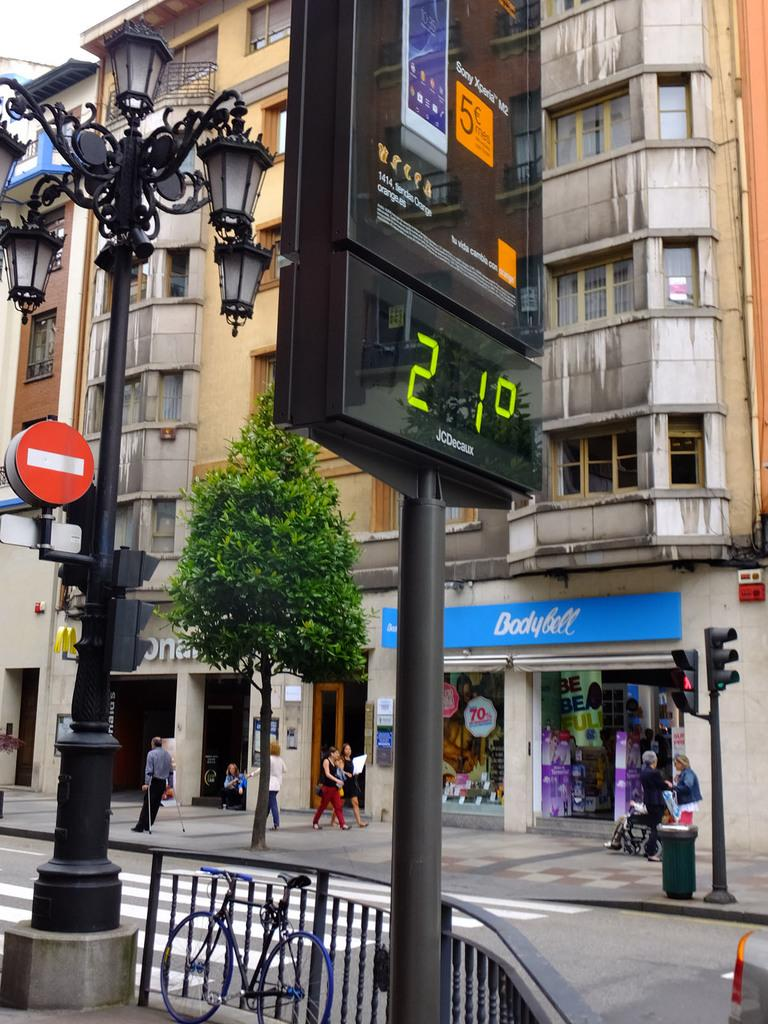What type of structures can be seen in the image? There are buildings in the image. What are some other objects visible in the image? Street poles, street lights, display screens, grills, a bicycle, bins, traffic poles, and traffic signals are visible in the image. Are there any commercial establishments in the image? Yes, stores are visible in the image. What is the presence of persons walking on the road suggest? It suggests that there is pedestrian activity in the area. Who is the owner of the fish seen in the image? There are no fish present in the image. What type of curtain is hanging in the image? There is no curtain present in the image. 